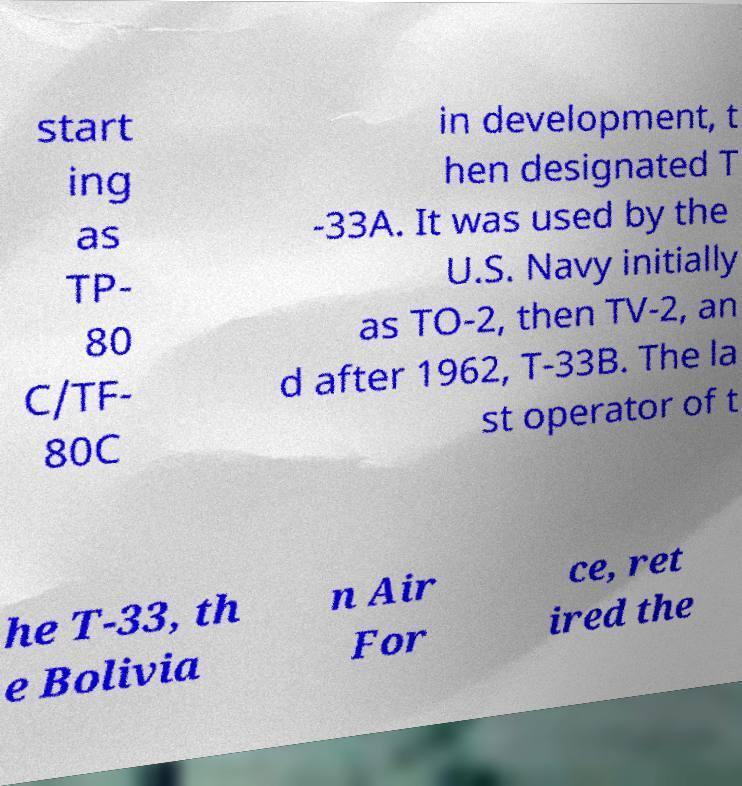Can you read and provide the text displayed in the image?This photo seems to have some interesting text. Can you extract and type it out for me? start ing as TP- 80 C/TF- 80C in development, t hen designated T -33A. It was used by the U.S. Navy initially as TO-2, then TV-2, an d after 1962, T-33B. The la st operator of t he T-33, th e Bolivia n Air For ce, ret ired the 